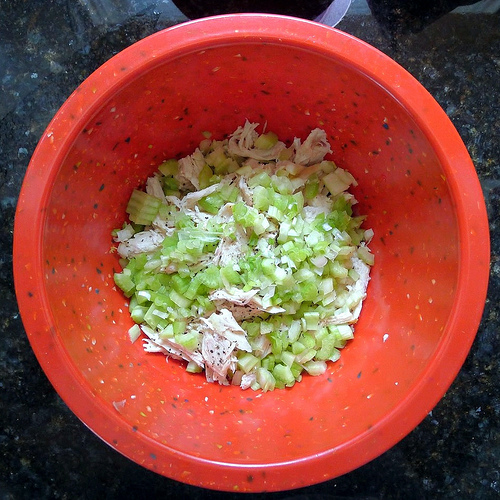<image>
Is the food behind the bowl? No. The food is not behind the bowl. From this viewpoint, the food appears to be positioned elsewhere in the scene. 